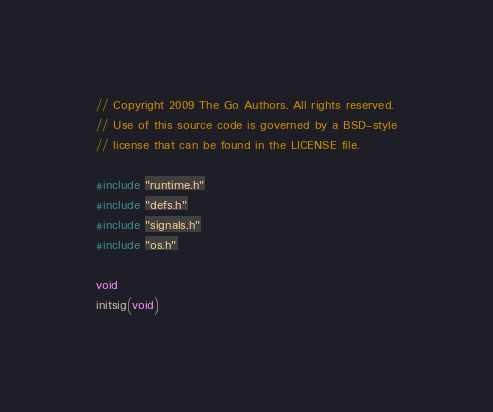Convert code to text. <code><loc_0><loc_0><loc_500><loc_500><_C_>// Copyright 2009 The Go Authors. All rights reserved.
// Use of this source code is governed by a BSD-style
// license that can be found in the LICENSE file.

#include "runtime.h"
#include "defs.h"
#include "signals.h"
#include "os.h"

void
initsig(void)</code> 